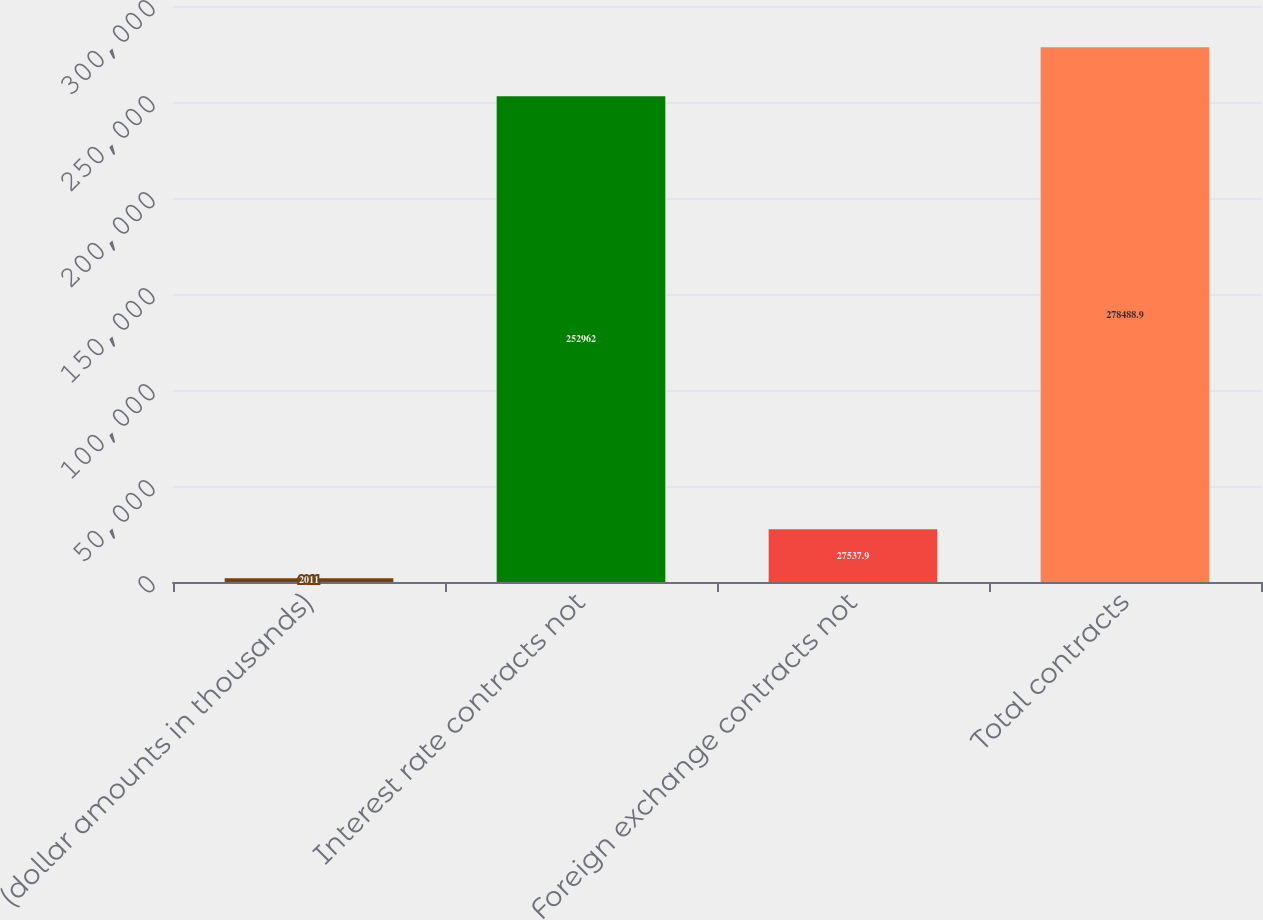Convert chart. <chart><loc_0><loc_0><loc_500><loc_500><bar_chart><fcel>(dollar amounts in thousands)<fcel>Interest rate contracts not<fcel>Foreign exchange contracts not<fcel>Total contracts<nl><fcel>2011<fcel>252962<fcel>27537.9<fcel>278489<nl></chart> 